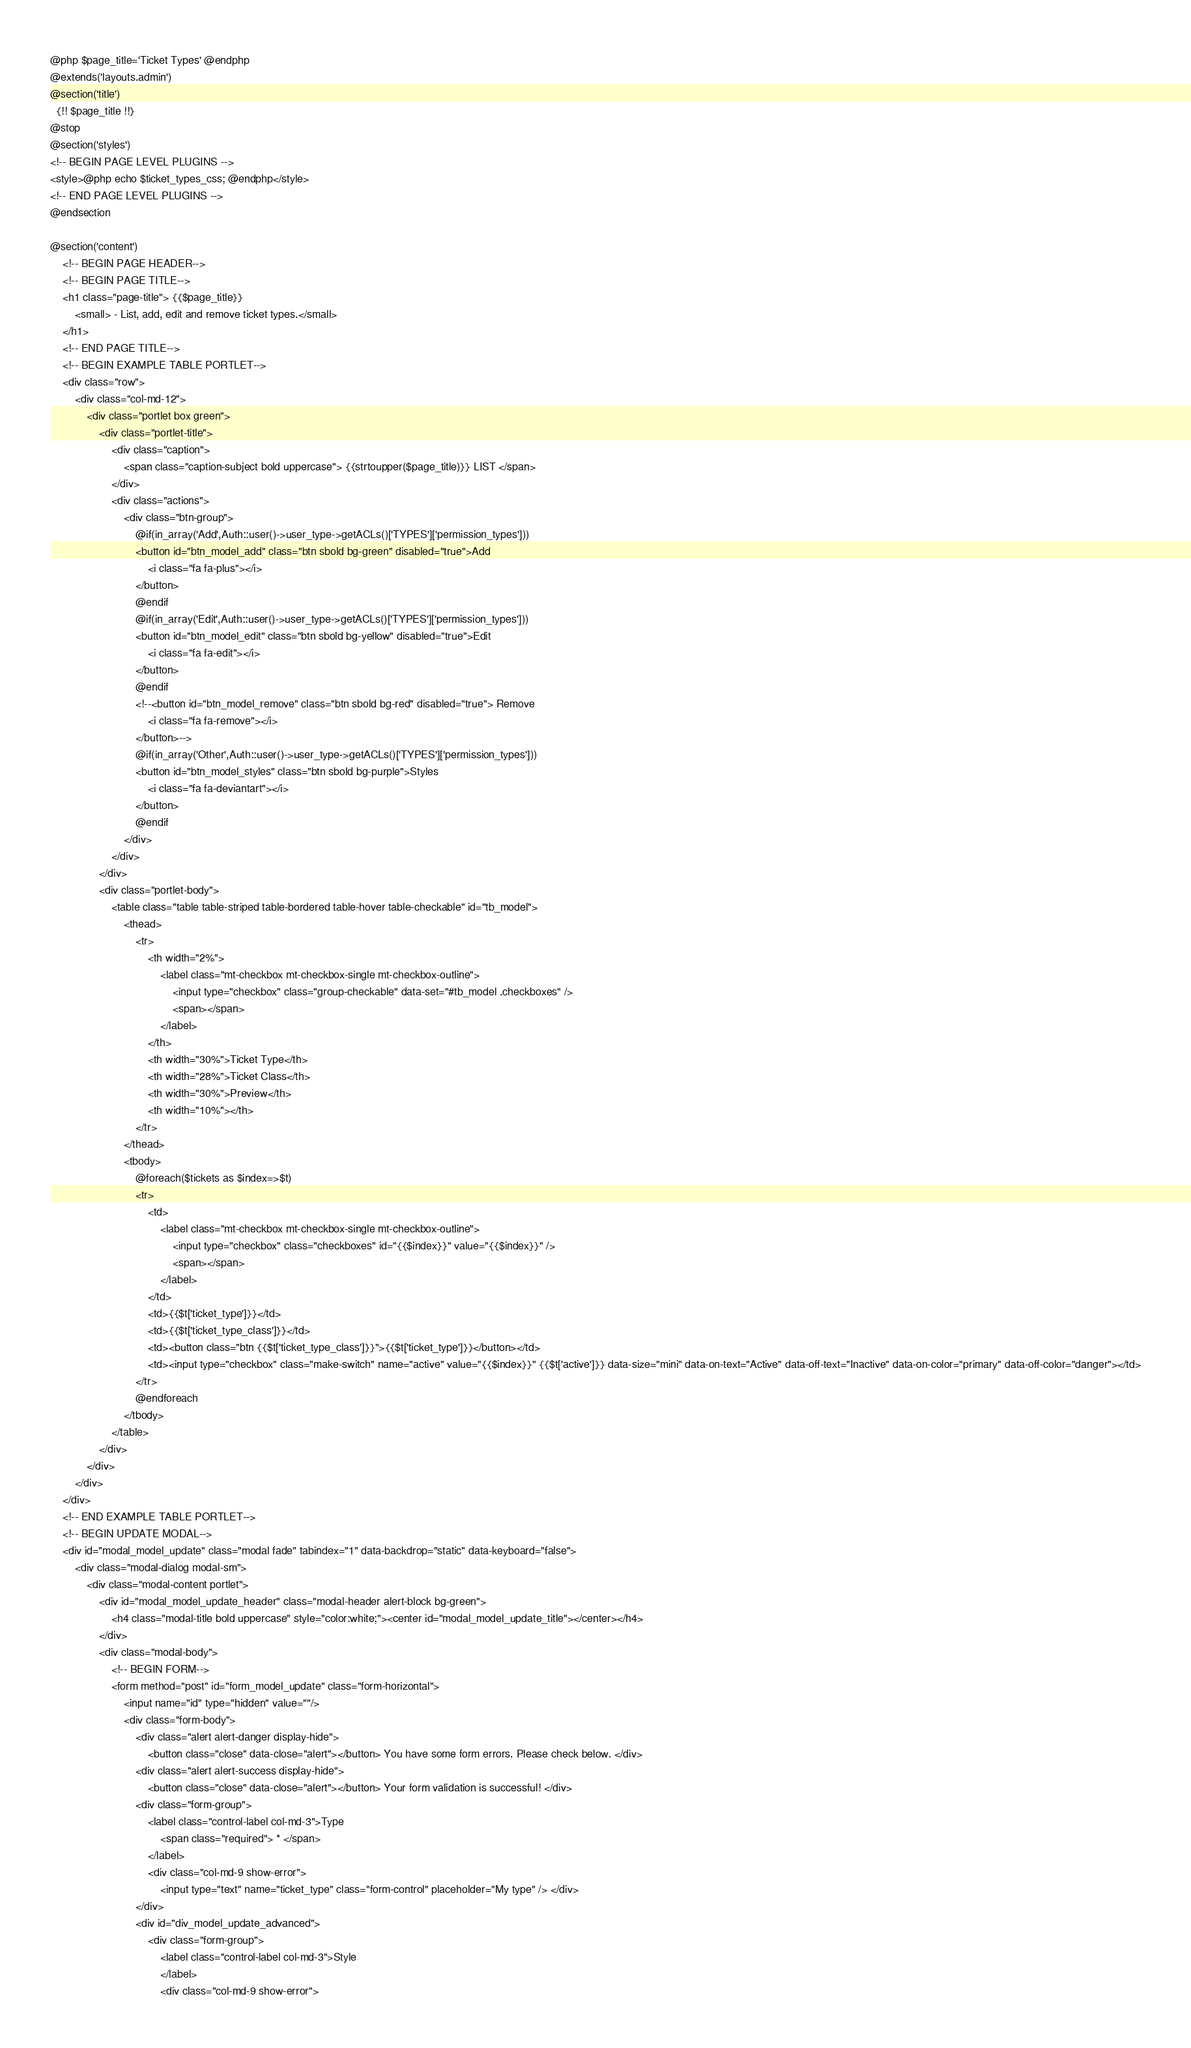<code> <loc_0><loc_0><loc_500><loc_500><_PHP_>@php $page_title='Ticket Types' @endphp
@extends('layouts.admin')
@section('title')
  {!! $page_title !!}
@stop
@section('styles')
<!-- BEGIN PAGE LEVEL PLUGINS -->
<style>@php echo $ticket_types_css; @endphp</style>
<!-- END PAGE LEVEL PLUGINS -->
@endsection

@section('content')
    <!-- BEGIN PAGE HEADER-->
    <!-- BEGIN PAGE TITLE-->
    <h1 class="page-title"> {{$page_title}}
        <small> - List, add, edit and remove ticket types.</small>
    </h1>
    <!-- END PAGE TITLE-->
    <!-- BEGIN EXAMPLE TABLE PORTLET-->
    <div class="row">
        <div class="col-md-12">
            <div class="portlet box green">
                <div class="portlet-title">
                    <div class="caption">
                        <span class="caption-subject bold uppercase"> {{strtoupper($page_title)}} LIST </span>
                    </div>
                    <div class="actions">
                        <div class="btn-group">
                            @if(in_array('Add',Auth::user()->user_type->getACLs()['TYPES']['permission_types']))
                            <button id="btn_model_add" class="btn sbold bg-green" disabled="true">Add
                                <i class="fa fa-plus"></i>
                            </button>
                            @endif
                            @if(in_array('Edit',Auth::user()->user_type->getACLs()['TYPES']['permission_types']))
                            <button id="btn_model_edit" class="btn sbold bg-yellow" disabled="true">Edit
                                <i class="fa fa-edit"></i>
                            </button>
                            @endif
                            <!--<button id="btn_model_remove" class="btn sbold bg-red" disabled="true"> Remove
                                <i class="fa fa-remove"></i>
                            </button>-->
                            @if(in_array('Other',Auth::user()->user_type->getACLs()['TYPES']['permission_types']))
                            <button id="btn_model_styles" class="btn sbold bg-purple">Styles
                                <i class="fa fa-deviantart"></i>
                            </button>
                            @endif
                        </div>
                    </div>
                </div>
                <div class="portlet-body">
                    <table class="table table-striped table-bordered table-hover table-checkable" id="tb_model">
                        <thead>
                            <tr>
                                <th width="2%">
                                    <label class="mt-checkbox mt-checkbox-single mt-checkbox-outline">
                                        <input type="checkbox" class="group-checkable" data-set="#tb_model .checkboxes" />
                                        <span></span>
                                    </label>
                                </th>
                                <th width="30%">Ticket Type</th>
                                <th width="28%">Ticket Class</th>
                                <th width="30%">Preview</th>
                                <th width="10%"></th>
                            </tr>
                        </thead>
                        <tbody>
                            @foreach($tickets as $index=>$t)
                            <tr>
                                <td>
                                    <label class="mt-checkbox mt-checkbox-single mt-checkbox-outline">
                                        <input type="checkbox" class="checkboxes" id="{{$index}}" value="{{$index}}" />
                                        <span></span>
                                    </label>
                                </td>
                                <td>{{$t['ticket_type']}}</td>
                                <td>{{$t['ticket_type_class']}}</td>
                                <td><button class="btn {{$t['ticket_type_class']}}">{{$t['ticket_type']}}</button></td>
                                <td><input type="checkbox" class="make-switch" name="active" value="{{$index}}" {{$t['active']}} data-size="mini" data-on-text="Active" data-off-text="Inactive" data-on-color="primary" data-off-color="danger"></td>
                            </tr>
                            @endforeach
                        </tbody>
                    </table>
                </div>
            </div>
        </div>
    </div>
    <!-- END EXAMPLE TABLE PORTLET-->
    <!-- BEGIN UPDATE MODAL-->
    <div id="modal_model_update" class="modal fade" tabindex="1" data-backdrop="static" data-keyboard="false">
        <div class="modal-dialog modal-sm">
            <div class="modal-content portlet">
                <div id="modal_model_update_header" class="modal-header alert-block bg-green">
                    <h4 class="modal-title bold uppercase" style="color:white;"><center id="modal_model_update_title"></center></h4>
                </div>
                <div class="modal-body">
                    <!-- BEGIN FORM-->
                    <form method="post" id="form_model_update" class="form-horizontal">
                        <input name="id" type="hidden" value=""/>
                        <div class="form-body">
                            <div class="alert alert-danger display-hide">
                                <button class="close" data-close="alert"></button> You have some form errors. Please check below. </div>
                            <div class="alert alert-success display-hide">
                                <button class="close" data-close="alert"></button> Your form validation is successful! </div>
                            <div class="form-group">
                                <label class="control-label col-md-3">Type
                                    <span class="required"> * </span>
                                </label>
                                <div class="col-md-9 show-error">
                                    <input type="text" name="ticket_type" class="form-control" placeholder="My type" /> </div>
                            </div>
                            <div id="div_model_update_advanced">
                                <div class="form-group">
                                    <label class="control-label col-md-3">Style
                                    </label>
                                    <div class="col-md-9 show-error"></code> 